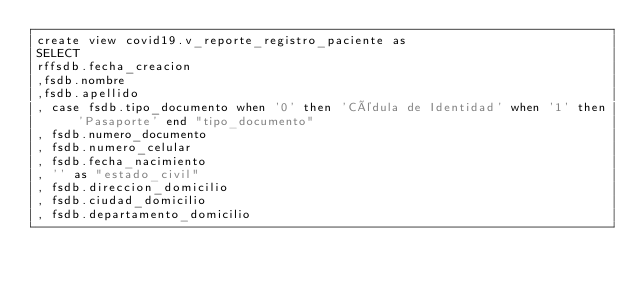<code> <loc_0><loc_0><loc_500><loc_500><_SQL_>create view covid19.v_reporte_registro_paciente as
SELECT 
rffsdb.fecha_creacion
,fsdb.nombre
,fsdb.apellido
, case fsdb.tipo_documento when '0' then 'Cédula de Identidad' when '1' then 'Pasaporte' end "tipo_documento"
, fsdb.numero_documento
, fsdb.numero_celular
, fsdb.fecha_nacimiento
, '' as "estado_civil"
, fsdb.direccion_domicilio
, fsdb.ciudad_domicilio
, fsdb.departamento_domicilio</code> 